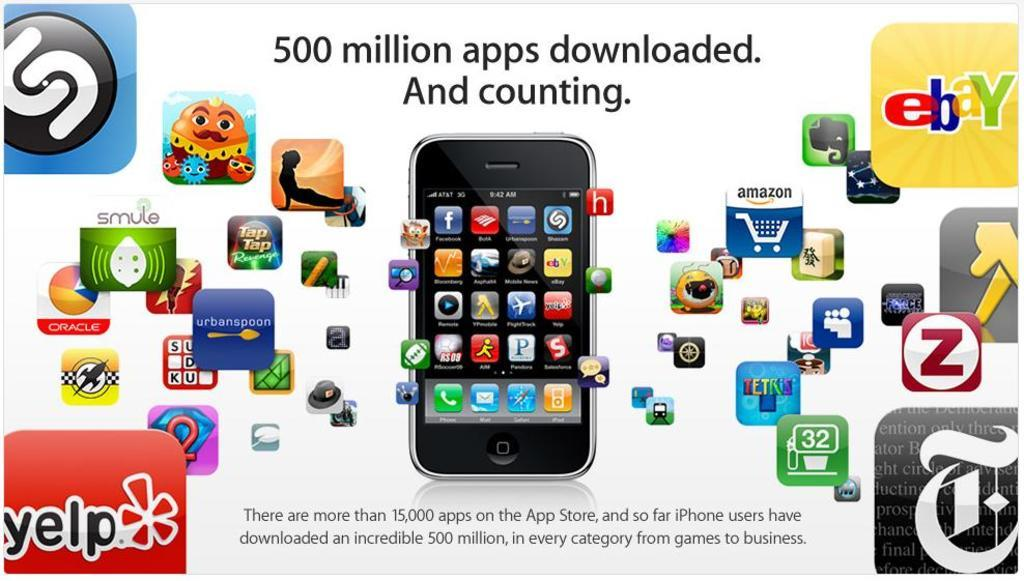<image>
Create a compact narrative representing the image presented. a message on the bottom left that says Yelp 